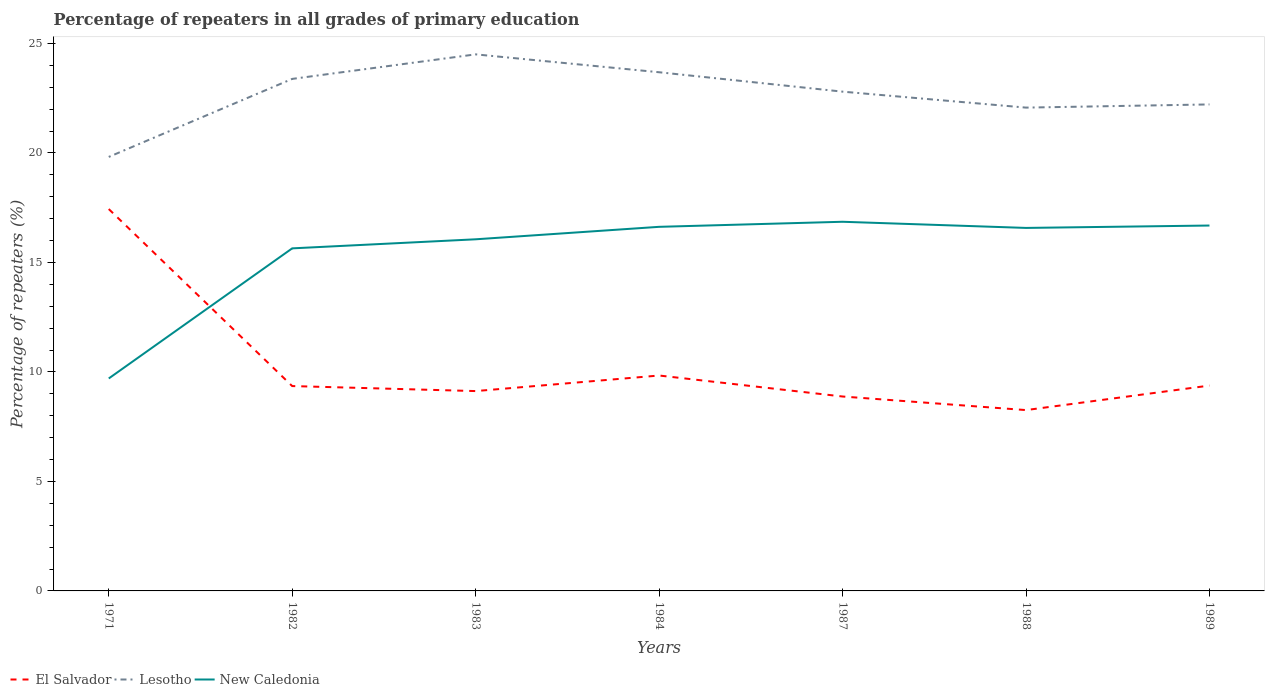How many different coloured lines are there?
Your answer should be compact. 3. Does the line corresponding to El Salvador intersect with the line corresponding to Lesotho?
Offer a very short reply. No. Is the number of lines equal to the number of legend labels?
Make the answer very short. Yes. Across all years, what is the maximum percentage of repeaters in El Salvador?
Give a very brief answer. 8.26. What is the total percentage of repeaters in El Salvador in the graph?
Your response must be concise. 8.56. What is the difference between the highest and the second highest percentage of repeaters in El Salvador?
Provide a succinct answer. 9.18. What is the difference between the highest and the lowest percentage of repeaters in El Salvador?
Your response must be concise. 1. How many lines are there?
Your answer should be very brief. 3. What is the difference between two consecutive major ticks on the Y-axis?
Keep it short and to the point. 5. Are the values on the major ticks of Y-axis written in scientific E-notation?
Offer a terse response. No. Does the graph contain any zero values?
Make the answer very short. No. How are the legend labels stacked?
Keep it short and to the point. Horizontal. What is the title of the graph?
Offer a very short reply. Percentage of repeaters in all grades of primary education. What is the label or title of the Y-axis?
Ensure brevity in your answer.  Percentage of repeaters (%). What is the Percentage of repeaters (%) in El Salvador in 1971?
Offer a terse response. 17.44. What is the Percentage of repeaters (%) in Lesotho in 1971?
Your answer should be compact. 19.82. What is the Percentage of repeaters (%) of New Caledonia in 1971?
Offer a very short reply. 9.7. What is the Percentage of repeaters (%) in El Salvador in 1982?
Provide a succinct answer. 9.35. What is the Percentage of repeaters (%) in Lesotho in 1982?
Provide a succinct answer. 23.38. What is the Percentage of repeaters (%) of New Caledonia in 1982?
Ensure brevity in your answer.  15.64. What is the Percentage of repeaters (%) of El Salvador in 1983?
Provide a succinct answer. 9.12. What is the Percentage of repeaters (%) in Lesotho in 1983?
Offer a terse response. 24.5. What is the Percentage of repeaters (%) of New Caledonia in 1983?
Provide a succinct answer. 16.06. What is the Percentage of repeaters (%) of El Salvador in 1984?
Your response must be concise. 9.84. What is the Percentage of repeaters (%) in Lesotho in 1984?
Your answer should be very brief. 23.68. What is the Percentage of repeaters (%) in New Caledonia in 1984?
Your response must be concise. 16.62. What is the Percentage of repeaters (%) in El Salvador in 1987?
Keep it short and to the point. 8.88. What is the Percentage of repeaters (%) of Lesotho in 1987?
Your answer should be compact. 22.8. What is the Percentage of repeaters (%) in New Caledonia in 1987?
Provide a succinct answer. 16.86. What is the Percentage of repeaters (%) in El Salvador in 1988?
Offer a very short reply. 8.26. What is the Percentage of repeaters (%) of Lesotho in 1988?
Your answer should be compact. 22.07. What is the Percentage of repeaters (%) in New Caledonia in 1988?
Offer a very short reply. 16.57. What is the Percentage of repeaters (%) in El Salvador in 1989?
Your answer should be compact. 9.38. What is the Percentage of repeaters (%) of Lesotho in 1989?
Your answer should be very brief. 22.21. What is the Percentage of repeaters (%) in New Caledonia in 1989?
Offer a very short reply. 16.68. Across all years, what is the maximum Percentage of repeaters (%) in El Salvador?
Make the answer very short. 17.44. Across all years, what is the maximum Percentage of repeaters (%) in Lesotho?
Your answer should be very brief. 24.5. Across all years, what is the maximum Percentage of repeaters (%) in New Caledonia?
Give a very brief answer. 16.86. Across all years, what is the minimum Percentage of repeaters (%) in El Salvador?
Offer a terse response. 8.26. Across all years, what is the minimum Percentage of repeaters (%) of Lesotho?
Give a very brief answer. 19.82. Across all years, what is the minimum Percentage of repeaters (%) of New Caledonia?
Your response must be concise. 9.7. What is the total Percentage of repeaters (%) of El Salvador in the graph?
Give a very brief answer. 72.26. What is the total Percentage of repeaters (%) in Lesotho in the graph?
Provide a short and direct response. 158.46. What is the total Percentage of repeaters (%) of New Caledonia in the graph?
Offer a terse response. 108.14. What is the difference between the Percentage of repeaters (%) of El Salvador in 1971 and that in 1982?
Provide a short and direct response. 8.08. What is the difference between the Percentage of repeaters (%) in Lesotho in 1971 and that in 1982?
Make the answer very short. -3.56. What is the difference between the Percentage of repeaters (%) in New Caledonia in 1971 and that in 1982?
Make the answer very short. -5.94. What is the difference between the Percentage of repeaters (%) in El Salvador in 1971 and that in 1983?
Make the answer very short. 8.31. What is the difference between the Percentage of repeaters (%) in Lesotho in 1971 and that in 1983?
Your answer should be very brief. -4.68. What is the difference between the Percentage of repeaters (%) of New Caledonia in 1971 and that in 1983?
Your answer should be compact. -6.35. What is the difference between the Percentage of repeaters (%) in El Salvador in 1971 and that in 1984?
Provide a succinct answer. 7.6. What is the difference between the Percentage of repeaters (%) of Lesotho in 1971 and that in 1984?
Give a very brief answer. -3.87. What is the difference between the Percentage of repeaters (%) of New Caledonia in 1971 and that in 1984?
Give a very brief answer. -6.92. What is the difference between the Percentage of repeaters (%) in El Salvador in 1971 and that in 1987?
Provide a succinct answer. 8.56. What is the difference between the Percentage of repeaters (%) of Lesotho in 1971 and that in 1987?
Offer a very short reply. -2.98. What is the difference between the Percentage of repeaters (%) of New Caledonia in 1971 and that in 1987?
Your answer should be very brief. -7.16. What is the difference between the Percentage of repeaters (%) of El Salvador in 1971 and that in 1988?
Provide a short and direct response. 9.18. What is the difference between the Percentage of repeaters (%) of Lesotho in 1971 and that in 1988?
Provide a succinct answer. -2.25. What is the difference between the Percentage of repeaters (%) of New Caledonia in 1971 and that in 1988?
Make the answer very short. -6.87. What is the difference between the Percentage of repeaters (%) in El Salvador in 1971 and that in 1989?
Give a very brief answer. 8.06. What is the difference between the Percentage of repeaters (%) of Lesotho in 1971 and that in 1989?
Your answer should be very brief. -2.4. What is the difference between the Percentage of repeaters (%) of New Caledonia in 1971 and that in 1989?
Make the answer very short. -6.98. What is the difference between the Percentage of repeaters (%) of El Salvador in 1982 and that in 1983?
Provide a short and direct response. 0.23. What is the difference between the Percentage of repeaters (%) of Lesotho in 1982 and that in 1983?
Keep it short and to the point. -1.12. What is the difference between the Percentage of repeaters (%) in New Caledonia in 1982 and that in 1983?
Provide a short and direct response. -0.41. What is the difference between the Percentage of repeaters (%) of El Salvador in 1982 and that in 1984?
Keep it short and to the point. -0.48. What is the difference between the Percentage of repeaters (%) of Lesotho in 1982 and that in 1984?
Your response must be concise. -0.3. What is the difference between the Percentage of repeaters (%) of New Caledonia in 1982 and that in 1984?
Ensure brevity in your answer.  -0.98. What is the difference between the Percentage of repeaters (%) in El Salvador in 1982 and that in 1987?
Your answer should be compact. 0.48. What is the difference between the Percentage of repeaters (%) in Lesotho in 1982 and that in 1987?
Give a very brief answer. 0.58. What is the difference between the Percentage of repeaters (%) in New Caledonia in 1982 and that in 1987?
Give a very brief answer. -1.21. What is the difference between the Percentage of repeaters (%) of El Salvador in 1982 and that in 1988?
Your answer should be very brief. 1.1. What is the difference between the Percentage of repeaters (%) of Lesotho in 1982 and that in 1988?
Provide a succinct answer. 1.31. What is the difference between the Percentage of repeaters (%) in New Caledonia in 1982 and that in 1988?
Provide a short and direct response. -0.93. What is the difference between the Percentage of repeaters (%) of El Salvador in 1982 and that in 1989?
Offer a very short reply. -0.02. What is the difference between the Percentage of repeaters (%) of Lesotho in 1982 and that in 1989?
Keep it short and to the point. 1.17. What is the difference between the Percentage of repeaters (%) of New Caledonia in 1982 and that in 1989?
Offer a terse response. -1.04. What is the difference between the Percentage of repeaters (%) in El Salvador in 1983 and that in 1984?
Offer a very short reply. -0.71. What is the difference between the Percentage of repeaters (%) of Lesotho in 1983 and that in 1984?
Ensure brevity in your answer.  0.82. What is the difference between the Percentage of repeaters (%) of New Caledonia in 1983 and that in 1984?
Ensure brevity in your answer.  -0.57. What is the difference between the Percentage of repeaters (%) of El Salvador in 1983 and that in 1987?
Offer a very short reply. 0.25. What is the difference between the Percentage of repeaters (%) of Lesotho in 1983 and that in 1987?
Make the answer very short. 1.7. What is the difference between the Percentage of repeaters (%) of New Caledonia in 1983 and that in 1987?
Your response must be concise. -0.8. What is the difference between the Percentage of repeaters (%) in El Salvador in 1983 and that in 1988?
Your answer should be compact. 0.87. What is the difference between the Percentage of repeaters (%) of Lesotho in 1983 and that in 1988?
Provide a succinct answer. 2.43. What is the difference between the Percentage of repeaters (%) of New Caledonia in 1983 and that in 1988?
Provide a short and direct response. -0.52. What is the difference between the Percentage of repeaters (%) of El Salvador in 1983 and that in 1989?
Ensure brevity in your answer.  -0.25. What is the difference between the Percentage of repeaters (%) of Lesotho in 1983 and that in 1989?
Give a very brief answer. 2.29. What is the difference between the Percentage of repeaters (%) of New Caledonia in 1983 and that in 1989?
Provide a short and direct response. -0.63. What is the difference between the Percentage of repeaters (%) of El Salvador in 1984 and that in 1987?
Your response must be concise. 0.96. What is the difference between the Percentage of repeaters (%) in Lesotho in 1984 and that in 1987?
Ensure brevity in your answer.  0.89. What is the difference between the Percentage of repeaters (%) in New Caledonia in 1984 and that in 1987?
Your response must be concise. -0.23. What is the difference between the Percentage of repeaters (%) of El Salvador in 1984 and that in 1988?
Your answer should be very brief. 1.58. What is the difference between the Percentage of repeaters (%) in Lesotho in 1984 and that in 1988?
Provide a short and direct response. 1.61. What is the difference between the Percentage of repeaters (%) in New Caledonia in 1984 and that in 1988?
Offer a terse response. 0.05. What is the difference between the Percentage of repeaters (%) of El Salvador in 1984 and that in 1989?
Offer a terse response. 0.46. What is the difference between the Percentage of repeaters (%) in Lesotho in 1984 and that in 1989?
Your response must be concise. 1.47. What is the difference between the Percentage of repeaters (%) of New Caledonia in 1984 and that in 1989?
Offer a very short reply. -0.06. What is the difference between the Percentage of repeaters (%) in El Salvador in 1987 and that in 1988?
Ensure brevity in your answer.  0.62. What is the difference between the Percentage of repeaters (%) of Lesotho in 1987 and that in 1988?
Your answer should be very brief. 0.73. What is the difference between the Percentage of repeaters (%) of New Caledonia in 1987 and that in 1988?
Your answer should be compact. 0.28. What is the difference between the Percentage of repeaters (%) of El Salvador in 1987 and that in 1989?
Give a very brief answer. -0.5. What is the difference between the Percentage of repeaters (%) in Lesotho in 1987 and that in 1989?
Ensure brevity in your answer.  0.58. What is the difference between the Percentage of repeaters (%) in New Caledonia in 1987 and that in 1989?
Offer a terse response. 0.17. What is the difference between the Percentage of repeaters (%) in El Salvador in 1988 and that in 1989?
Keep it short and to the point. -1.12. What is the difference between the Percentage of repeaters (%) in Lesotho in 1988 and that in 1989?
Provide a short and direct response. -0.15. What is the difference between the Percentage of repeaters (%) in New Caledonia in 1988 and that in 1989?
Your answer should be compact. -0.11. What is the difference between the Percentage of repeaters (%) of El Salvador in 1971 and the Percentage of repeaters (%) of Lesotho in 1982?
Keep it short and to the point. -5.94. What is the difference between the Percentage of repeaters (%) of El Salvador in 1971 and the Percentage of repeaters (%) of New Caledonia in 1982?
Make the answer very short. 1.8. What is the difference between the Percentage of repeaters (%) in Lesotho in 1971 and the Percentage of repeaters (%) in New Caledonia in 1982?
Your answer should be compact. 4.17. What is the difference between the Percentage of repeaters (%) in El Salvador in 1971 and the Percentage of repeaters (%) in Lesotho in 1983?
Your answer should be compact. -7.06. What is the difference between the Percentage of repeaters (%) of El Salvador in 1971 and the Percentage of repeaters (%) of New Caledonia in 1983?
Your answer should be very brief. 1.38. What is the difference between the Percentage of repeaters (%) of Lesotho in 1971 and the Percentage of repeaters (%) of New Caledonia in 1983?
Your answer should be compact. 3.76. What is the difference between the Percentage of repeaters (%) of El Salvador in 1971 and the Percentage of repeaters (%) of Lesotho in 1984?
Your answer should be very brief. -6.25. What is the difference between the Percentage of repeaters (%) in El Salvador in 1971 and the Percentage of repeaters (%) in New Caledonia in 1984?
Ensure brevity in your answer.  0.81. What is the difference between the Percentage of repeaters (%) of Lesotho in 1971 and the Percentage of repeaters (%) of New Caledonia in 1984?
Ensure brevity in your answer.  3.19. What is the difference between the Percentage of repeaters (%) of El Salvador in 1971 and the Percentage of repeaters (%) of Lesotho in 1987?
Provide a succinct answer. -5.36. What is the difference between the Percentage of repeaters (%) of El Salvador in 1971 and the Percentage of repeaters (%) of New Caledonia in 1987?
Provide a short and direct response. 0.58. What is the difference between the Percentage of repeaters (%) of Lesotho in 1971 and the Percentage of repeaters (%) of New Caledonia in 1987?
Give a very brief answer. 2.96. What is the difference between the Percentage of repeaters (%) of El Salvador in 1971 and the Percentage of repeaters (%) of Lesotho in 1988?
Your answer should be compact. -4.63. What is the difference between the Percentage of repeaters (%) of El Salvador in 1971 and the Percentage of repeaters (%) of New Caledonia in 1988?
Your answer should be compact. 0.86. What is the difference between the Percentage of repeaters (%) in Lesotho in 1971 and the Percentage of repeaters (%) in New Caledonia in 1988?
Offer a terse response. 3.24. What is the difference between the Percentage of repeaters (%) in El Salvador in 1971 and the Percentage of repeaters (%) in Lesotho in 1989?
Your answer should be compact. -4.78. What is the difference between the Percentage of repeaters (%) of El Salvador in 1971 and the Percentage of repeaters (%) of New Caledonia in 1989?
Offer a terse response. 0.75. What is the difference between the Percentage of repeaters (%) in Lesotho in 1971 and the Percentage of repeaters (%) in New Caledonia in 1989?
Provide a short and direct response. 3.13. What is the difference between the Percentage of repeaters (%) of El Salvador in 1982 and the Percentage of repeaters (%) of Lesotho in 1983?
Your response must be concise. -15.15. What is the difference between the Percentage of repeaters (%) in El Salvador in 1982 and the Percentage of repeaters (%) in New Caledonia in 1983?
Your answer should be very brief. -6.7. What is the difference between the Percentage of repeaters (%) of Lesotho in 1982 and the Percentage of repeaters (%) of New Caledonia in 1983?
Provide a succinct answer. 7.32. What is the difference between the Percentage of repeaters (%) of El Salvador in 1982 and the Percentage of repeaters (%) of Lesotho in 1984?
Make the answer very short. -14.33. What is the difference between the Percentage of repeaters (%) of El Salvador in 1982 and the Percentage of repeaters (%) of New Caledonia in 1984?
Your answer should be compact. -7.27. What is the difference between the Percentage of repeaters (%) in Lesotho in 1982 and the Percentage of repeaters (%) in New Caledonia in 1984?
Give a very brief answer. 6.75. What is the difference between the Percentage of repeaters (%) in El Salvador in 1982 and the Percentage of repeaters (%) in Lesotho in 1987?
Provide a short and direct response. -13.44. What is the difference between the Percentage of repeaters (%) in El Salvador in 1982 and the Percentage of repeaters (%) in New Caledonia in 1987?
Keep it short and to the point. -7.5. What is the difference between the Percentage of repeaters (%) of Lesotho in 1982 and the Percentage of repeaters (%) of New Caledonia in 1987?
Provide a short and direct response. 6.52. What is the difference between the Percentage of repeaters (%) in El Salvador in 1982 and the Percentage of repeaters (%) in Lesotho in 1988?
Offer a very short reply. -12.71. What is the difference between the Percentage of repeaters (%) of El Salvador in 1982 and the Percentage of repeaters (%) of New Caledonia in 1988?
Your response must be concise. -7.22. What is the difference between the Percentage of repeaters (%) of Lesotho in 1982 and the Percentage of repeaters (%) of New Caledonia in 1988?
Make the answer very short. 6.8. What is the difference between the Percentage of repeaters (%) in El Salvador in 1982 and the Percentage of repeaters (%) in Lesotho in 1989?
Provide a succinct answer. -12.86. What is the difference between the Percentage of repeaters (%) in El Salvador in 1982 and the Percentage of repeaters (%) in New Caledonia in 1989?
Your answer should be compact. -7.33. What is the difference between the Percentage of repeaters (%) of Lesotho in 1982 and the Percentage of repeaters (%) of New Caledonia in 1989?
Your response must be concise. 6.7. What is the difference between the Percentage of repeaters (%) of El Salvador in 1983 and the Percentage of repeaters (%) of Lesotho in 1984?
Offer a very short reply. -14.56. What is the difference between the Percentage of repeaters (%) in El Salvador in 1983 and the Percentage of repeaters (%) in New Caledonia in 1984?
Your answer should be very brief. -7.5. What is the difference between the Percentage of repeaters (%) of Lesotho in 1983 and the Percentage of repeaters (%) of New Caledonia in 1984?
Offer a terse response. 7.88. What is the difference between the Percentage of repeaters (%) in El Salvador in 1983 and the Percentage of repeaters (%) in Lesotho in 1987?
Make the answer very short. -13.67. What is the difference between the Percentage of repeaters (%) in El Salvador in 1983 and the Percentage of repeaters (%) in New Caledonia in 1987?
Your response must be concise. -7.73. What is the difference between the Percentage of repeaters (%) of Lesotho in 1983 and the Percentage of repeaters (%) of New Caledonia in 1987?
Your response must be concise. 7.64. What is the difference between the Percentage of repeaters (%) of El Salvador in 1983 and the Percentage of repeaters (%) of Lesotho in 1988?
Offer a terse response. -12.94. What is the difference between the Percentage of repeaters (%) of El Salvador in 1983 and the Percentage of repeaters (%) of New Caledonia in 1988?
Provide a succinct answer. -7.45. What is the difference between the Percentage of repeaters (%) of Lesotho in 1983 and the Percentage of repeaters (%) of New Caledonia in 1988?
Your response must be concise. 7.92. What is the difference between the Percentage of repeaters (%) in El Salvador in 1983 and the Percentage of repeaters (%) in Lesotho in 1989?
Ensure brevity in your answer.  -13.09. What is the difference between the Percentage of repeaters (%) of El Salvador in 1983 and the Percentage of repeaters (%) of New Caledonia in 1989?
Your response must be concise. -7.56. What is the difference between the Percentage of repeaters (%) of Lesotho in 1983 and the Percentage of repeaters (%) of New Caledonia in 1989?
Your answer should be compact. 7.82. What is the difference between the Percentage of repeaters (%) in El Salvador in 1984 and the Percentage of repeaters (%) in Lesotho in 1987?
Provide a succinct answer. -12.96. What is the difference between the Percentage of repeaters (%) in El Salvador in 1984 and the Percentage of repeaters (%) in New Caledonia in 1987?
Provide a short and direct response. -7.02. What is the difference between the Percentage of repeaters (%) of Lesotho in 1984 and the Percentage of repeaters (%) of New Caledonia in 1987?
Ensure brevity in your answer.  6.83. What is the difference between the Percentage of repeaters (%) in El Salvador in 1984 and the Percentage of repeaters (%) in Lesotho in 1988?
Give a very brief answer. -12.23. What is the difference between the Percentage of repeaters (%) of El Salvador in 1984 and the Percentage of repeaters (%) of New Caledonia in 1988?
Your answer should be very brief. -6.74. What is the difference between the Percentage of repeaters (%) of Lesotho in 1984 and the Percentage of repeaters (%) of New Caledonia in 1988?
Ensure brevity in your answer.  7.11. What is the difference between the Percentage of repeaters (%) in El Salvador in 1984 and the Percentage of repeaters (%) in Lesotho in 1989?
Offer a very short reply. -12.38. What is the difference between the Percentage of repeaters (%) in El Salvador in 1984 and the Percentage of repeaters (%) in New Caledonia in 1989?
Offer a very short reply. -6.85. What is the difference between the Percentage of repeaters (%) of Lesotho in 1984 and the Percentage of repeaters (%) of New Caledonia in 1989?
Give a very brief answer. 7. What is the difference between the Percentage of repeaters (%) in El Salvador in 1987 and the Percentage of repeaters (%) in Lesotho in 1988?
Give a very brief answer. -13.19. What is the difference between the Percentage of repeaters (%) of El Salvador in 1987 and the Percentage of repeaters (%) of New Caledonia in 1988?
Your answer should be compact. -7.7. What is the difference between the Percentage of repeaters (%) of Lesotho in 1987 and the Percentage of repeaters (%) of New Caledonia in 1988?
Provide a short and direct response. 6.22. What is the difference between the Percentage of repeaters (%) in El Salvador in 1987 and the Percentage of repeaters (%) in Lesotho in 1989?
Your answer should be very brief. -13.34. What is the difference between the Percentage of repeaters (%) of El Salvador in 1987 and the Percentage of repeaters (%) of New Caledonia in 1989?
Offer a very short reply. -7.81. What is the difference between the Percentage of repeaters (%) in Lesotho in 1987 and the Percentage of repeaters (%) in New Caledonia in 1989?
Offer a very short reply. 6.11. What is the difference between the Percentage of repeaters (%) of El Salvador in 1988 and the Percentage of repeaters (%) of Lesotho in 1989?
Offer a very short reply. -13.96. What is the difference between the Percentage of repeaters (%) of El Salvador in 1988 and the Percentage of repeaters (%) of New Caledonia in 1989?
Provide a short and direct response. -8.43. What is the difference between the Percentage of repeaters (%) in Lesotho in 1988 and the Percentage of repeaters (%) in New Caledonia in 1989?
Your response must be concise. 5.38. What is the average Percentage of repeaters (%) in El Salvador per year?
Keep it short and to the point. 10.32. What is the average Percentage of repeaters (%) in Lesotho per year?
Provide a succinct answer. 22.64. What is the average Percentage of repeaters (%) in New Caledonia per year?
Your answer should be compact. 15.45. In the year 1971, what is the difference between the Percentage of repeaters (%) of El Salvador and Percentage of repeaters (%) of Lesotho?
Keep it short and to the point. -2.38. In the year 1971, what is the difference between the Percentage of repeaters (%) of El Salvador and Percentage of repeaters (%) of New Caledonia?
Your response must be concise. 7.74. In the year 1971, what is the difference between the Percentage of repeaters (%) of Lesotho and Percentage of repeaters (%) of New Caledonia?
Give a very brief answer. 10.12. In the year 1982, what is the difference between the Percentage of repeaters (%) of El Salvador and Percentage of repeaters (%) of Lesotho?
Keep it short and to the point. -14.03. In the year 1982, what is the difference between the Percentage of repeaters (%) in El Salvador and Percentage of repeaters (%) in New Caledonia?
Provide a short and direct response. -6.29. In the year 1982, what is the difference between the Percentage of repeaters (%) of Lesotho and Percentage of repeaters (%) of New Caledonia?
Give a very brief answer. 7.74. In the year 1983, what is the difference between the Percentage of repeaters (%) of El Salvador and Percentage of repeaters (%) of Lesotho?
Provide a short and direct response. -15.37. In the year 1983, what is the difference between the Percentage of repeaters (%) of El Salvador and Percentage of repeaters (%) of New Caledonia?
Ensure brevity in your answer.  -6.93. In the year 1983, what is the difference between the Percentage of repeaters (%) in Lesotho and Percentage of repeaters (%) in New Caledonia?
Your answer should be very brief. 8.44. In the year 1984, what is the difference between the Percentage of repeaters (%) in El Salvador and Percentage of repeaters (%) in Lesotho?
Ensure brevity in your answer.  -13.85. In the year 1984, what is the difference between the Percentage of repeaters (%) of El Salvador and Percentage of repeaters (%) of New Caledonia?
Your answer should be compact. -6.79. In the year 1984, what is the difference between the Percentage of repeaters (%) in Lesotho and Percentage of repeaters (%) in New Caledonia?
Ensure brevity in your answer.  7.06. In the year 1987, what is the difference between the Percentage of repeaters (%) in El Salvador and Percentage of repeaters (%) in Lesotho?
Your answer should be very brief. -13.92. In the year 1987, what is the difference between the Percentage of repeaters (%) of El Salvador and Percentage of repeaters (%) of New Caledonia?
Provide a succinct answer. -7.98. In the year 1987, what is the difference between the Percentage of repeaters (%) of Lesotho and Percentage of repeaters (%) of New Caledonia?
Your answer should be very brief. 5.94. In the year 1988, what is the difference between the Percentage of repeaters (%) in El Salvador and Percentage of repeaters (%) in Lesotho?
Offer a very short reply. -13.81. In the year 1988, what is the difference between the Percentage of repeaters (%) in El Salvador and Percentage of repeaters (%) in New Caledonia?
Provide a short and direct response. -8.32. In the year 1988, what is the difference between the Percentage of repeaters (%) in Lesotho and Percentage of repeaters (%) in New Caledonia?
Offer a terse response. 5.49. In the year 1989, what is the difference between the Percentage of repeaters (%) in El Salvador and Percentage of repeaters (%) in Lesotho?
Offer a terse response. -12.84. In the year 1989, what is the difference between the Percentage of repeaters (%) in El Salvador and Percentage of repeaters (%) in New Caledonia?
Provide a succinct answer. -7.31. In the year 1989, what is the difference between the Percentage of repeaters (%) of Lesotho and Percentage of repeaters (%) of New Caledonia?
Offer a very short reply. 5.53. What is the ratio of the Percentage of repeaters (%) in El Salvador in 1971 to that in 1982?
Give a very brief answer. 1.86. What is the ratio of the Percentage of repeaters (%) of Lesotho in 1971 to that in 1982?
Keep it short and to the point. 0.85. What is the ratio of the Percentage of repeaters (%) in New Caledonia in 1971 to that in 1982?
Offer a terse response. 0.62. What is the ratio of the Percentage of repeaters (%) of El Salvador in 1971 to that in 1983?
Make the answer very short. 1.91. What is the ratio of the Percentage of repeaters (%) in Lesotho in 1971 to that in 1983?
Offer a very short reply. 0.81. What is the ratio of the Percentage of repeaters (%) of New Caledonia in 1971 to that in 1983?
Provide a succinct answer. 0.6. What is the ratio of the Percentage of repeaters (%) of El Salvador in 1971 to that in 1984?
Your answer should be very brief. 1.77. What is the ratio of the Percentage of repeaters (%) in Lesotho in 1971 to that in 1984?
Keep it short and to the point. 0.84. What is the ratio of the Percentage of repeaters (%) of New Caledonia in 1971 to that in 1984?
Provide a succinct answer. 0.58. What is the ratio of the Percentage of repeaters (%) in El Salvador in 1971 to that in 1987?
Offer a very short reply. 1.96. What is the ratio of the Percentage of repeaters (%) in Lesotho in 1971 to that in 1987?
Offer a terse response. 0.87. What is the ratio of the Percentage of repeaters (%) in New Caledonia in 1971 to that in 1987?
Give a very brief answer. 0.58. What is the ratio of the Percentage of repeaters (%) of El Salvador in 1971 to that in 1988?
Provide a short and direct response. 2.11. What is the ratio of the Percentage of repeaters (%) of Lesotho in 1971 to that in 1988?
Give a very brief answer. 0.9. What is the ratio of the Percentage of repeaters (%) in New Caledonia in 1971 to that in 1988?
Ensure brevity in your answer.  0.59. What is the ratio of the Percentage of repeaters (%) of El Salvador in 1971 to that in 1989?
Give a very brief answer. 1.86. What is the ratio of the Percentage of repeaters (%) in Lesotho in 1971 to that in 1989?
Give a very brief answer. 0.89. What is the ratio of the Percentage of repeaters (%) of New Caledonia in 1971 to that in 1989?
Offer a terse response. 0.58. What is the ratio of the Percentage of repeaters (%) in El Salvador in 1982 to that in 1983?
Your answer should be very brief. 1.03. What is the ratio of the Percentage of repeaters (%) of Lesotho in 1982 to that in 1983?
Give a very brief answer. 0.95. What is the ratio of the Percentage of repeaters (%) in New Caledonia in 1982 to that in 1983?
Your answer should be compact. 0.97. What is the ratio of the Percentage of repeaters (%) of El Salvador in 1982 to that in 1984?
Your answer should be very brief. 0.95. What is the ratio of the Percentage of repeaters (%) in Lesotho in 1982 to that in 1984?
Offer a terse response. 0.99. What is the ratio of the Percentage of repeaters (%) of New Caledonia in 1982 to that in 1984?
Your response must be concise. 0.94. What is the ratio of the Percentage of repeaters (%) in El Salvador in 1982 to that in 1987?
Make the answer very short. 1.05. What is the ratio of the Percentage of repeaters (%) of Lesotho in 1982 to that in 1987?
Keep it short and to the point. 1.03. What is the ratio of the Percentage of repeaters (%) of New Caledonia in 1982 to that in 1987?
Provide a short and direct response. 0.93. What is the ratio of the Percentage of repeaters (%) in El Salvador in 1982 to that in 1988?
Keep it short and to the point. 1.13. What is the ratio of the Percentage of repeaters (%) of Lesotho in 1982 to that in 1988?
Ensure brevity in your answer.  1.06. What is the ratio of the Percentage of repeaters (%) of New Caledonia in 1982 to that in 1988?
Offer a very short reply. 0.94. What is the ratio of the Percentage of repeaters (%) in El Salvador in 1982 to that in 1989?
Give a very brief answer. 1. What is the ratio of the Percentage of repeaters (%) of Lesotho in 1982 to that in 1989?
Provide a succinct answer. 1.05. What is the ratio of the Percentage of repeaters (%) of El Salvador in 1983 to that in 1984?
Ensure brevity in your answer.  0.93. What is the ratio of the Percentage of repeaters (%) in Lesotho in 1983 to that in 1984?
Your response must be concise. 1.03. What is the ratio of the Percentage of repeaters (%) in New Caledonia in 1983 to that in 1984?
Provide a succinct answer. 0.97. What is the ratio of the Percentage of repeaters (%) of El Salvador in 1983 to that in 1987?
Keep it short and to the point. 1.03. What is the ratio of the Percentage of repeaters (%) in Lesotho in 1983 to that in 1987?
Offer a terse response. 1.07. What is the ratio of the Percentage of repeaters (%) in New Caledonia in 1983 to that in 1987?
Your answer should be compact. 0.95. What is the ratio of the Percentage of repeaters (%) in El Salvador in 1983 to that in 1988?
Offer a very short reply. 1.11. What is the ratio of the Percentage of repeaters (%) of Lesotho in 1983 to that in 1988?
Provide a short and direct response. 1.11. What is the ratio of the Percentage of repeaters (%) in New Caledonia in 1983 to that in 1988?
Provide a succinct answer. 0.97. What is the ratio of the Percentage of repeaters (%) in El Salvador in 1983 to that in 1989?
Ensure brevity in your answer.  0.97. What is the ratio of the Percentage of repeaters (%) of Lesotho in 1983 to that in 1989?
Offer a very short reply. 1.1. What is the ratio of the Percentage of repeaters (%) of New Caledonia in 1983 to that in 1989?
Keep it short and to the point. 0.96. What is the ratio of the Percentage of repeaters (%) of El Salvador in 1984 to that in 1987?
Make the answer very short. 1.11. What is the ratio of the Percentage of repeaters (%) of Lesotho in 1984 to that in 1987?
Make the answer very short. 1.04. What is the ratio of the Percentage of repeaters (%) of New Caledonia in 1984 to that in 1987?
Your response must be concise. 0.99. What is the ratio of the Percentage of repeaters (%) of El Salvador in 1984 to that in 1988?
Your response must be concise. 1.19. What is the ratio of the Percentage of repeaters (%) in Lesotho in 1984 to that in 1988?
Give a very brief answer. 1.07. What is the ratio of the Percentage of repeaters (%) of El Salvador in 1984 to that in 1989?
Provide a short and direct response. 1.05. What is the ratio of the Percentage of repeaters (%) in Lesotho in 1984 to that in 1989?
Offer a very short reply. 1.07. What is the ratio of the Percentage of repeaters (%) in New Caledonia in 1984 to that in 1989?
Your answer should be compact. 1. What is the ratio of the Percentage of repeaters (%) in El Salvador in 1987 to that in 1988?
Ensure brevity in your answer.  1.08. What is the ratio of the Percentage of repeaters (%) of Lesotho in 1987 to that in 1988?
Keep it short and to the point. 1.03. What is the ratio of the Percentage of repeaters (%) of New Caledonia in 1987 to that in 1988?
Keep it short and to the point. 1.02. What is the ratio of the Percentage of repeaters (%) in El Salvador in 1987 to that in 1989?
Your response must be concise. 0.95. What is the ratio of the Percentage of repeaters (%) in Lesotho in 1987 to that in 1989?
Your response must be concise. 1.03. What is the ratio of the Percentage of repeaters (%) in New Caledonia in 1987 to that in 1989?
Offer a very short reply. 1.01. What is the ratio of the Percentage of repeaters (%) of El Salvador in 1988 to that in 1989?
Offer a very short reply. 0.88. What is the ratio of the Percentage of repeaters (%) of Lesotho in 1988 to that in 1989?
Offer a terse response. 0.99. What is the difference between the highest and the second highest Percentage of repeaters (%) in El Salvador?
Keep it short and to the point. 7.6. What is the difference between the highest and the second highest Percentage of repeaters (%) of Lesotho?
Your answer should be very brief. 0.82. What is the difference between the highest and the second highest Percentage of repeaters (%) in New Caledonia?
Provide a short and direct response. 0.17. What is the difference between the highest and the lowest Percentage of repeaters (%) in El Salvador?
Provide a short and direct response. 9.18. What is the difference between the highest and the lowest Percentage of repeaters (%) of Lesotho?
Provide a short and direct response. 4.68. What is the difference between the highest and the lowest Percentage of repeaters (%) in New Caledonia?
Your answer should be very brief. 7.16. 